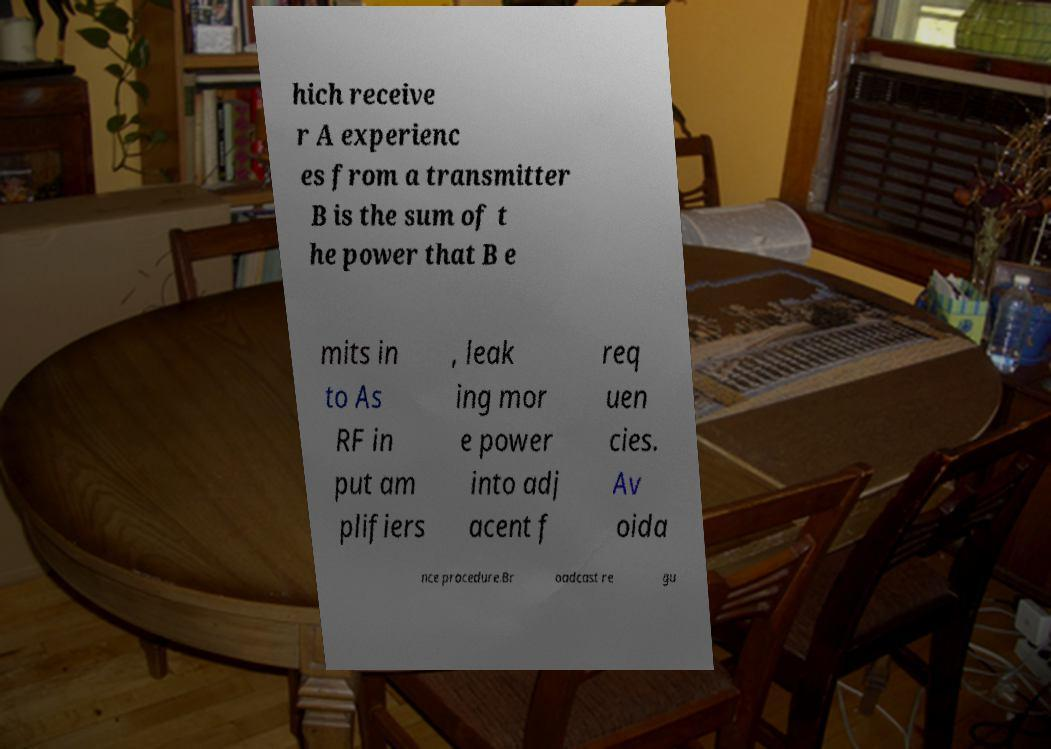Please read and relay the text visible in this image. What does it say? hich receive r A experienc es from a transmitter B is the sum of t he power that B e mits in to As RF in put am plifiers , leak ing mor e power into adj acent f req uen cies. Av oida nce procedure.Br oadcast re gu 